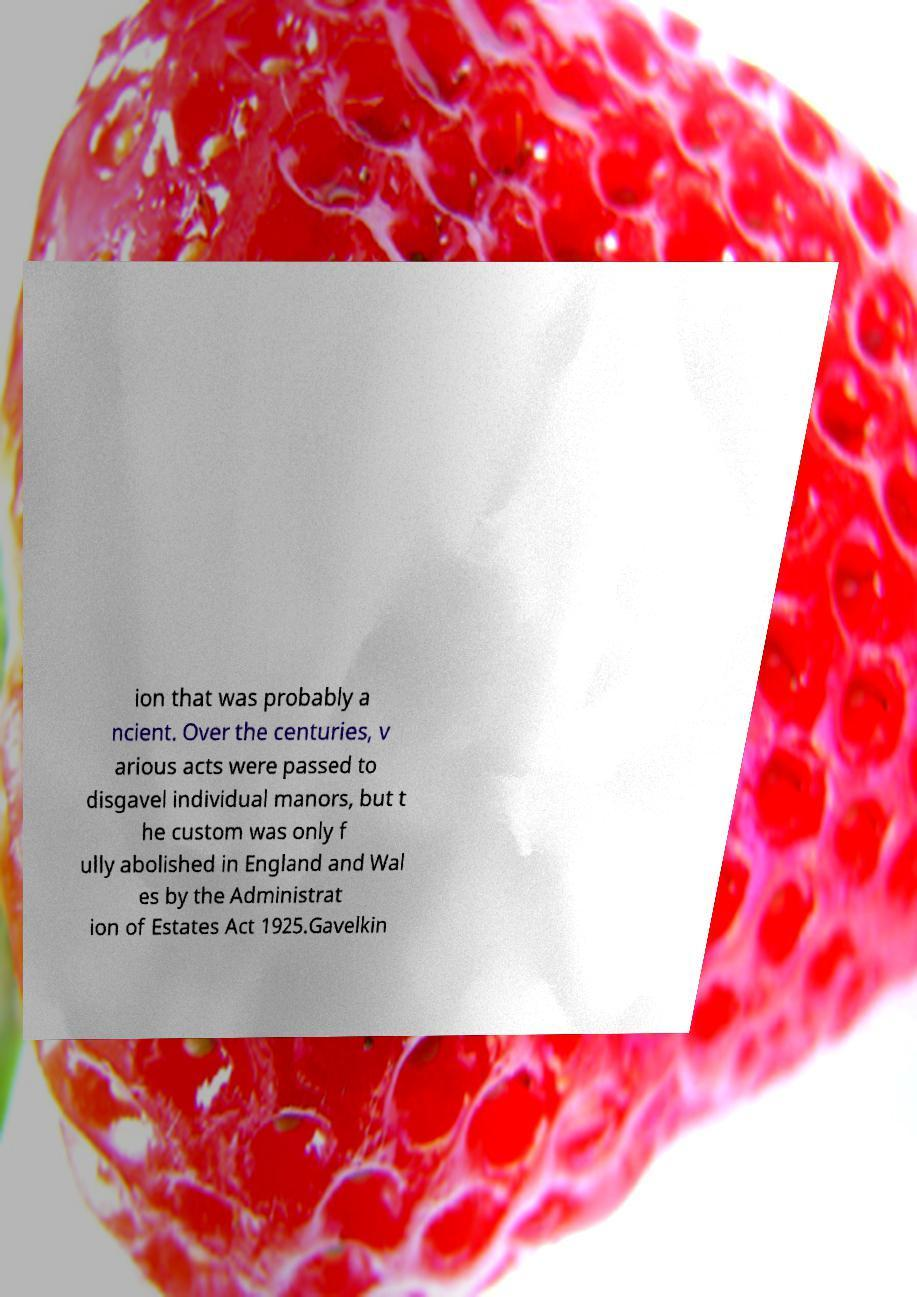Could you extract and type out the text from this image? ion that was probably a ncient. Over the centuries, v arious acts were passed to disgavel individual manors, but t he custom was only f ully abolished in England and Wal es by the Administrat ion of Estates Act 1925.Gavelkin 